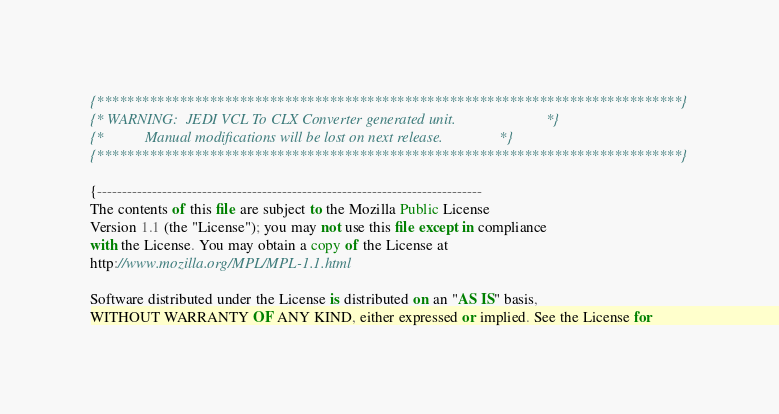Convert code to text. <code><loc_0><loc_0><loc_500><loc_500><_Pascal_>{******************************************************************************}
{* WARNING:  JEDI VCL To CLX Converter generated unit.                        *}
{*           Manual modifications will be lost on next release.               *}
{******************************************************************************}

{-----------------------------------------------------------------------------
The contents of this file are subject to the Mozilla Public License
Version 1.1 (the "License"); you may not use this file except in compliance
with the License. You may obtain a copy of the License at
http://www.mozilla.org/MPL/MPL-1.1.html

Software distributed under the License is distributed on an "AS IS" basis,
WITHOUT WARRANTY OF ANY KIND, either expressed or implied. See the License for</code> 